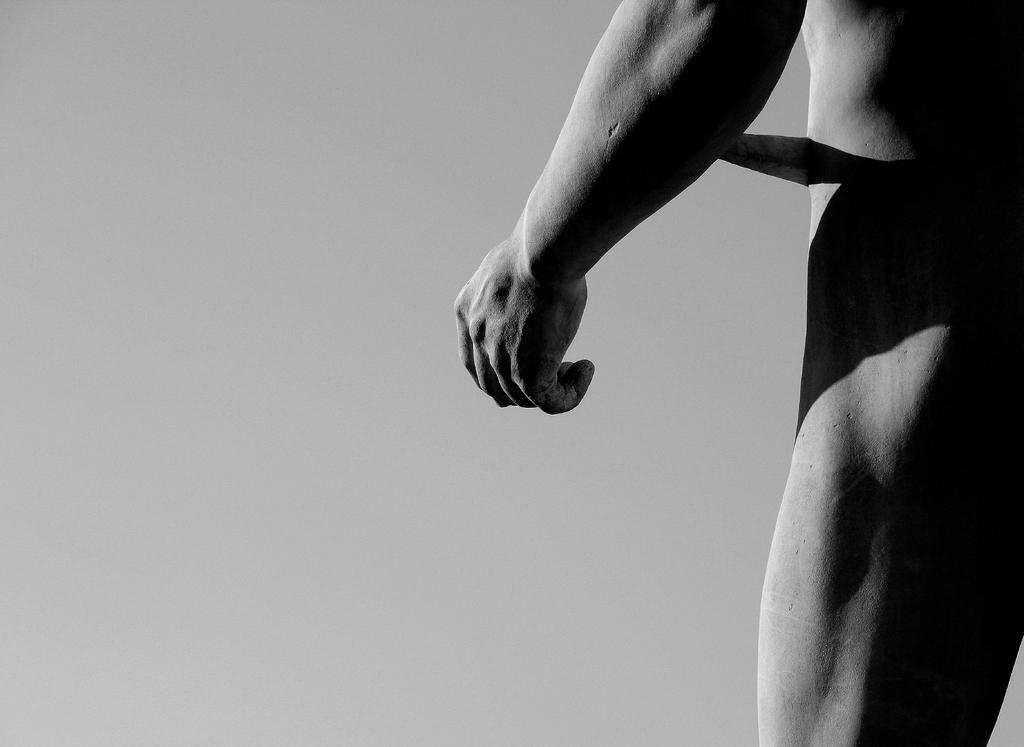What is located on the right side of the image? There is a person on the right side of the image. What can be seen in the background of the image? There is a wall in the background of the image. What color scheme is used in the image? The image is black and white. Can you see any smoke coming from the person's mouth in the image? There is no smoke visible in the image, as it is black and white and does not depict any such activity. 